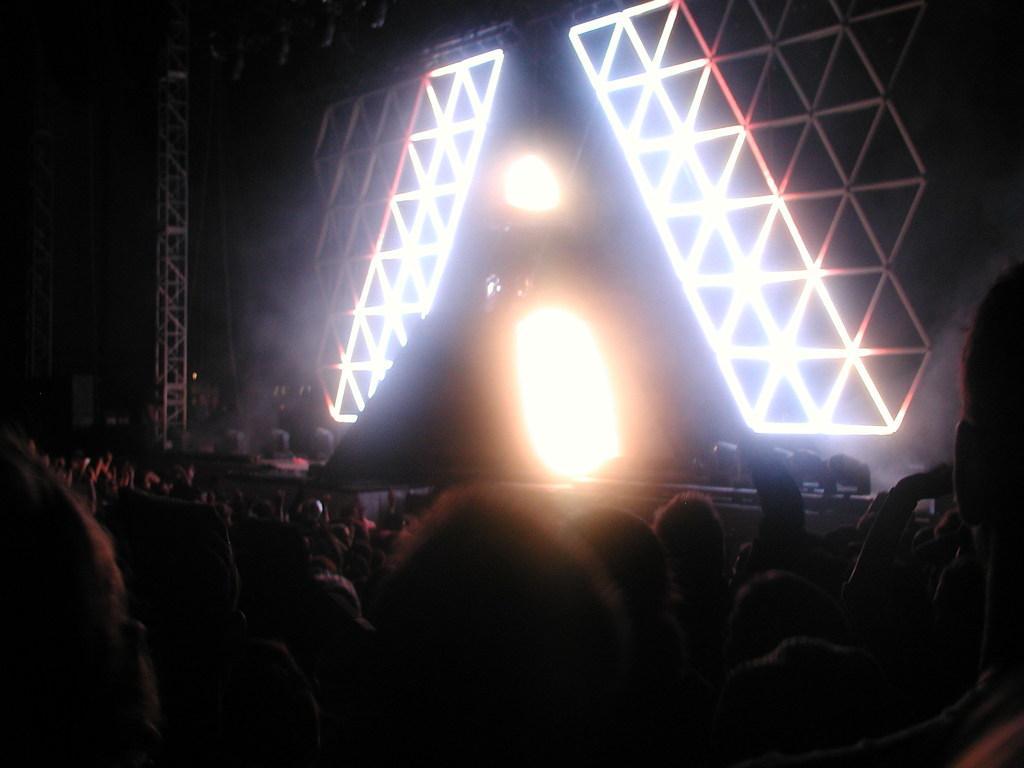Can you describe this image briefly? In this image I can see the group of people. In-front of these people I can see the stage. On the stage I can see the lights and metal rods. And there is a black background. 